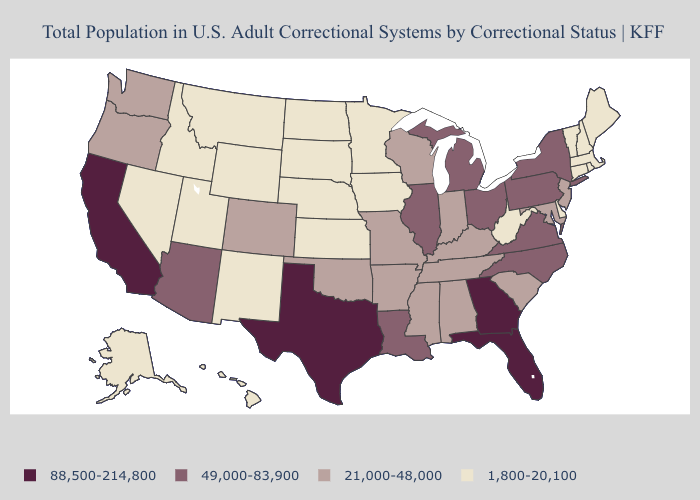Name the states that have a value in the range 49,000-83,900?
Keep it brief. Arizona, Illinois, Louisiana, Michigan, New York, North Carolina, Ohio, Pennsylvania, Virginia. Does Utah have the highest value in the USA?
Give a very brief answer. No. Does Nebraska have the lowest value in the MidWest?
Be succinct. Yes. What is the value of New Hampshire?
Quick response, please. 1,800-20,100. What is the value of Alaska?
Quick response, please. 1,800-20,100. Which states have the lowest value in the USA?
Write a very short answer. Alaska, Connecticut, Delaware, Hawaii, Idaho, Iowa, Kansas, Maine, Massachusetts, Minnesota, Montana, Nebraska, Nevada, New Hampshire, New Mexico, North Dakota, Rhode Island, South Dakota, Utah, Vermont, West Virginia, Wyoming. Name the states that have a value in the range 49,000-83,900?
Keep it brief. Arizona, Illinois, Louisiana, Michigan, New York, North Carolina, Ohio, Pennsylvania, Virginia. What is the value of North Dakota?
Keep it brief. 1,800-20,100. Which states have the highest value in the USA?
Write a very short answer. California, Florida, Georgia, Texas. What is the value of New Jersey?
Keep it brief. 21,000-48,000. Is the legend a continuous bar?
Answer briefly. No. Name the states that have a value in the range 49,000-83,900?
Give a very brief answer. Arizona, Illinois, Louisiana, Michigan, New York, North Carolina, Ohio, Pennsylvania, Virginia. Name the states that have a value in the range 1,800-20,100?
Quick response, please. Alaska, Connecticut, Delaware, Hawaii, Idaho, Iowa, Kansas, Maine, Massachusetts, Minnesota, Montana, Nebraska, Nevada, New Hampshire, New Mexico, North Dakota, Rhode Island, South Dakota, Utah, Vermont, West Virginia, Wyoming. What is the value of California?
Give a very brief answer. 88,500-214,800. Which states hav the highest value in the Northeast?
Be succinct. New York, Pennsylvania. 